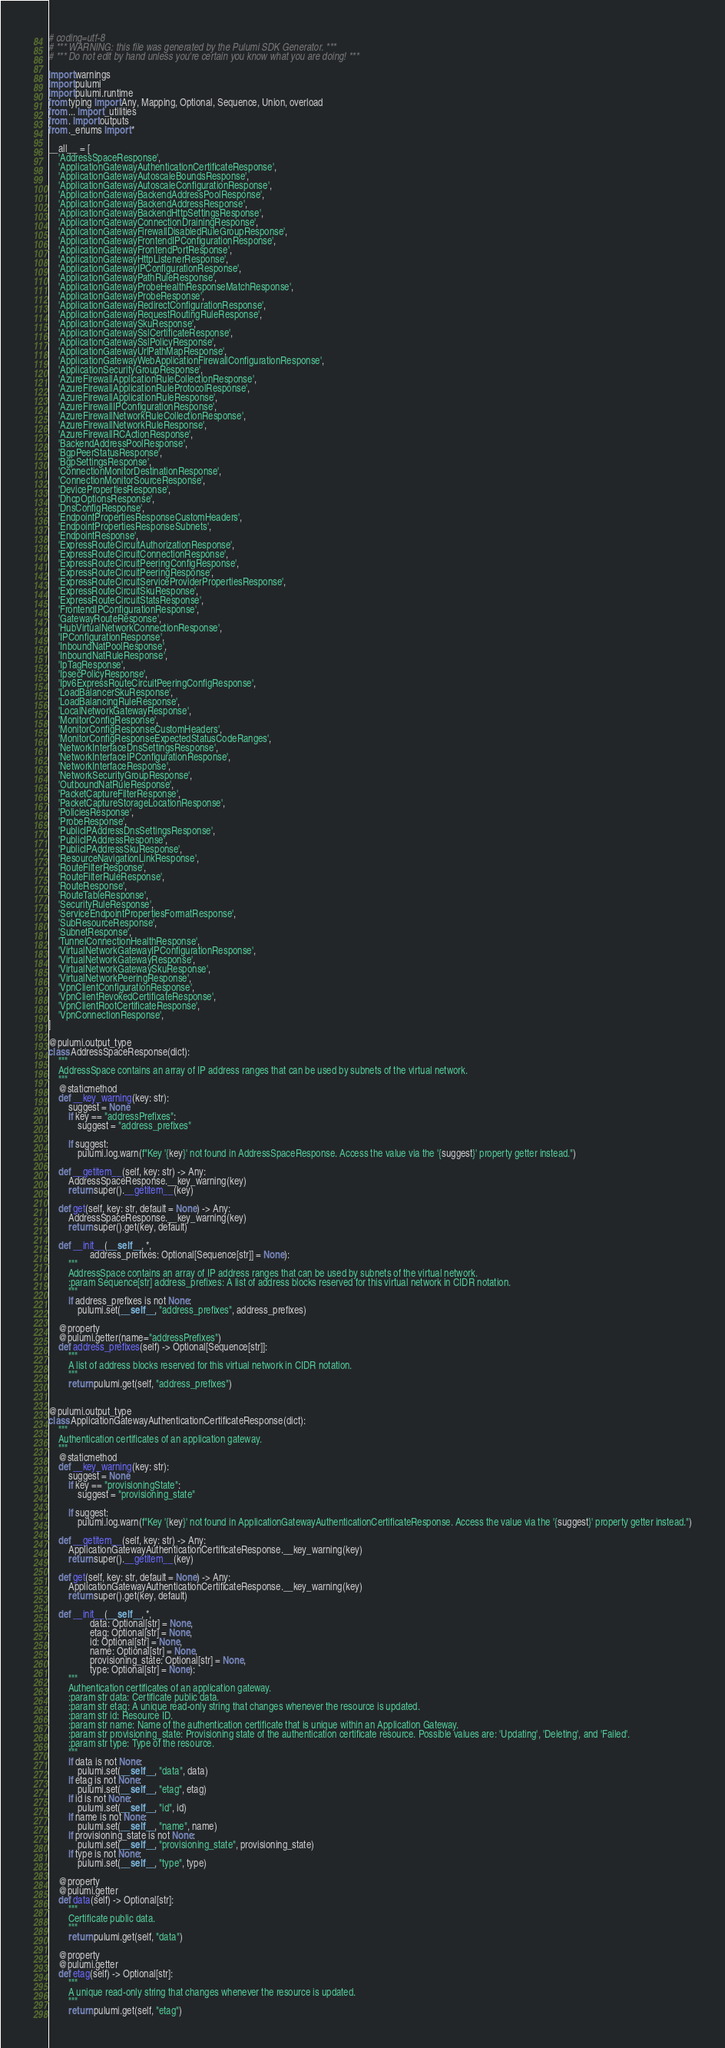<code> <loc_0><loc_0><loc_500><loc_500><_Python_># coding=utf-8
# *** WARNING: this file was generated by the Pulumi SDK Generator. ***
# *** Do not edit by hand unless you're certain you know what you are doing! ***

import warnings
import pulumi
import pulumi.runtime
from typing import Any, Mapping, Optional, Sequence, Union, overload
from ... import _utilities
from . import outputs
from ._enums import *

__all__ = [
    'AddressSpaceResponse',
    'ApplicationGatewayAuthenticationCertificateResponse',
    'ApplicationGatewayAutoscaleBoundsResponse',
    'ApplicationGatewayAutoscaleConfigurationResponse',
    'ApplicationGatewayBackendAddressPoolResponse',
    'ApplicationGatewayBackendAddressResponse',
    'ApplicationGatewayBackendHttpSettingsResponse',
    'ApplicationGatewayConnectionDrainingResponse',
    'ApplicationGatewayFirewallDisabledRuleGroupResponse',
    'ApplicationGatewayFrontendIPConfigurationResponse',
    'ApplicationGatewayFrontendPortResponse',
    'ApplicationGatewayHttpListenerResponse',
    'ApplicationGatewayIPConfigurationResponse',
    'ApplicationGatewayPathRuleResponse',
    'ApplicationGatewayProbeHealthResponseMatchResponse',
    'ApplicationGatewayProbeResponse',
    'ApplicationGatewayRedirectConfigurationResponse',
    'ApplicationGatewayRequestRoutingRuleResponse',
    'ApplicationGatewaySkuResponse',
    'ApplicationGatewaySslCertificateResponse',
    'ApplicationGatewaySslPolicyResponse',
    'ApplicationGatewayUrlPathMapResponse',
    'ApplicationGatewayWebApplicationFirewallConfigurationResponse',
    'ApplicationSecurityGroupResponse',
    'AzureFirewallApplicationRuleCollectionResponse',
    'AzureFirewallApplicationRuleProtocolResponse',
    'AzureFirewallApplicationRuleResponse',
    'AzureFirewallIPConfigurationResponse',
    'AzureFirewallNetworkRuleCollectionResponse',
    'AzureFirewallNetworkRuleResponse',
    'AzureFirewallRCActionResponse',
    'BackendAddressPoolResponse',
    'BgpPeerStatusResponse',
    'BgpSettingsResponse',
    'ConnectionMonitorDestinationResponse',
    'ConnectionMonitorSourceResponse',
    'DevicePropertiesResponse',
    'DhcpOptionsResponse',
    'DnsConfigResponse',
    'EndpointPropertiesResponseCustomHeaders',
    'EndpointPropertiesResponseSubnets',
    'EndpointResponse',
    'ExpressRouteCircuitAuthorizationResponse',
    'ExpressRouteCircuitConnectionResponse',
    'ExpressRouteCircuitPeeringConfigResponse',
    'ExpressRouteCircuitPeeringResponse',
    'ExpressRouteCircuitServiceProviderPropertiesResponse',
    'ExpressRouteCircuitSkuResponse',
    'ExpressRouteCircuitStatsResponse',
    'FrontendIPConfigurationResponse',
    'GatewayRouteResponse',
    'HubVirtualNetworkConnectionResponse',
    'IPConfigurationResponse',
    'InboundNatPoolResponse',
    'InboundNatRuleResponse',
    'IpTagResponse',
    'IpsecPolicyResponse',
    'Ipv6ExpressRouteCircuitPeeringConfigResponse',
    'LoadBalancerSkuResponse',
    'LoadBalancingRuleResponse',
    'LocalNetworkGatewayResponse',
    'MonitorConfigResponse',
    'MonitorConfigResponseCustomHeaders',
    'MonitorConfigResponseExpectedStatusCodeRanges',
    'NetworkInterfaceDnsSettingsResponse',
    'NetworkInterfaceIPConfigurationResponse',
    'NetworkInterfaceResponse',
    'NetworkSecurityGroupResponse',
    'OutboundNatRuleResponse',
    'PacketCaptureFilterResponse',
    'PacketCaptureStorageLocationResponse',
    'PoliciesResponse',
    'ProbeResponse',
    'PublicIPAddressDnsSettingsResponse',
    'PublicIPAddressResponse',
    'PublicIPAddressSkuResponse',
    'ResourceNavigationLinkResponse',
    'RouteFilterResponse',
    'RouteFilterRuleResponse',
    'RouteResponse',
    'RouteTableResponse',
    'SecurityRuleResponse',
    'ServiceEndpointPropertiesFormatResponse',
    'SubResourceResponse',
    'SubnetResponse',
    'TunnelConnectionHealthResponse',
    'VirtualNetworkGatewayIPConfigurationResponse',
    'VirtualNetworkGatewayResponse',
    'VirtualNetworkGatewaySkuResponse',
    'VirtualNetworkPeeringResponse',
    'VpnClientConfigurationResponse',
    'VpnClientRevokedCertificateResponse',
    'VpnClientRootCertificateResponse',
    'VpnConnectionResponse',
]

@pulumi.output_type
class AddressSpaceResponse(dict):
    """
    AddressSpace contains an array of IP address ranges that can be used by subnets of the virtual network.
    """
    @staticmethod
    def __key_warning(key: str):
        suggest = None
        if key == "addressPrefixes":
            suggest = "address_prefixes"

        if suggest:
            pulumi.log.warn(f"Key '{key}' not found in AddressSpaceResponse. Access the value via the '{suggest}' property getter instead.")

    def __getitem__(self, key: str) -> Any:
        AddressSpaceResponse.__key_warning(key)
        return super().__getitem__(key)

    def get(self, key: str, default = None) -> Any:
        AddressSpaceResponse.__key_warning(key)
        return super().get(key, default)

    def __init__(__self__, *,
                 address_prefixes: Optional[Sequence[str]] = None):
        """
        AddressSpace contains an array of IP address ranges that can be used by subnets of the virtual network.
        :param Sequence[str] address_prefixes: A list of address blocks reserved for this virtual network in CIDR notation.
        """
        if address_prefixes is not None:
            pulumi.set(__self__, "address_prefixes", address_prefixes)

    @property
    @pulumi.getter(name="addressPrefixes")
    def address_prefixes(self) -> Optional[Sequence[str]]:
        """
        A list of address blocks reserved for this virtual network in CIDR notation.
        """
        return pulumi.get(self, "address_prefixes")


@pulumi.output_type
class ApplicationGatewayAuthenticationCertificateResponse(dict):
    """
    Authentication certificates of an application gateway.
    """
    @staticmethod
    def __key_warning(key: str):
        suggest = None
        if key == "provisioningState":
            suggest = "provisioning_state"

        if suggest:
            pulumi.log.warn(f"Key '{key}' not found in ApplicationGatewayAuthenticationCertificateResponse. Access the value via the '{suggest}' property getter instead.")

    def __getitem__(self, key: str) -> Any:
        ApplicationGatewayAuthenticationCertificateResponse.__key_warning(key)
        return super().__getitem__(key)

    def get(self, key: str, default = None) -> Any:
        ApplicationGatewayAuthenticationCertificateResponse.__key_warning(key)
        return super().get(key, default)

    def __init__(__self__, *,
                 data: Optional[str] = None,
                 etag: Optional[str] = None,
                 id: Optional[str] = None,
                 name: Optional[str] = None,
                 provisioning_state: Optional[str] = None,
                 type: Optional[str] = None):
        """
        Authentication certificates of an application gateway.
        :param str data: Certificate public data.
        :param str etag: A unique read-only string that changes whenever the resource is updated.
        :param str id: Resource ID.
        :param str name: Name of the authentication certificate that is unique within an Application Gateway.
        :param str provisioning_state: Provisioning state of the authentication certificate resource. Possible values are: 'Updating', 'Deleting', and 'Failed'.
        :param str type: Type of the resource.
        """
        if data is not None:
            pulumi.set(__self__, "data", data)
        if etag is not None:
            pulumi.set(__self__, "etag", etag)
        if id is not None:
            pulumi.set(__self__, "id", id)
        if name is not None:
            pulumi.set(__self__, "name", name)
        if provisioning_state is not None:
            pulumi.set(__self__, "provisioning_state", provisioning_state)
        if type is not None:
            pulumi.set(__self__, "type", type)

    @property
    @pulumi.getter
    def data(self) -> Optional[str]:
        """
        Certificate public data.
        """
        return pulumi.get(self, "data")

    @property
    @pulumi.getter
    def etag(self) -> Optional[str]:
        """
        A unique read-only string that changes whenever the resource is updated.
        """
        return pulumi.get(self, "etag")
</code> 